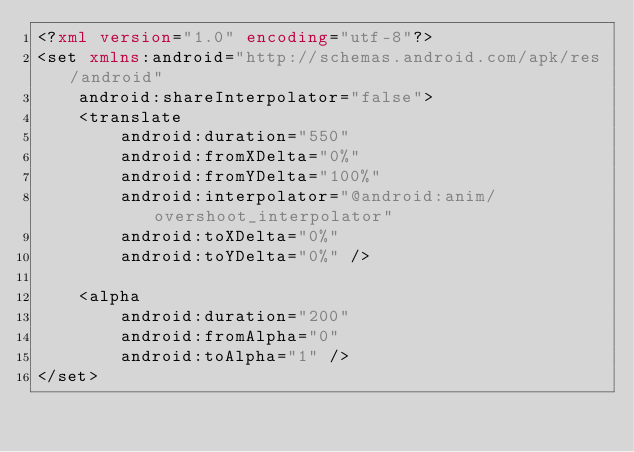<code> <loc_0><loc_0><loc_500><loc_500><_XML_><?xml version="1.0" encoding="utf-8"?>
<set xmlns:android="http://schemas.android.com/apk/res/android"
    android:shareInterpolator="false">
    <translate
        android:duration="550"
        android:fromXDelta="0%"
        android:fromYDelta="100%"
        android:interpolator="@android:anim/overshoot_interpolator"
        android:toXDelta="0%"
        android:toYDelta="0%" />

    <alpha
        android:duration="200"
        android:fromAlpha="0"
        android:toAlpha="1" />
</set>
</code> 